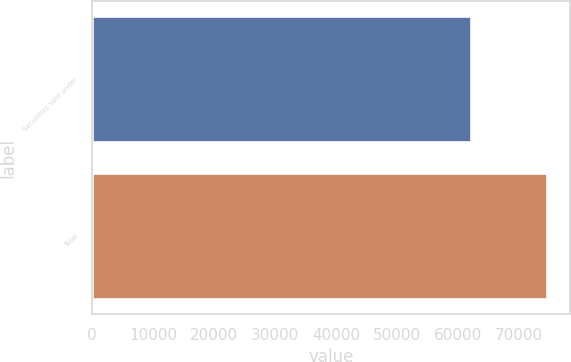Convert chart to OTSL. <chart><loc_0><loc_0><loc_500><loc_500><bar_chart><fcel>Securities sold under<fcel>Total<nl><fcel>62168<fcel>74597<nl></chart> 